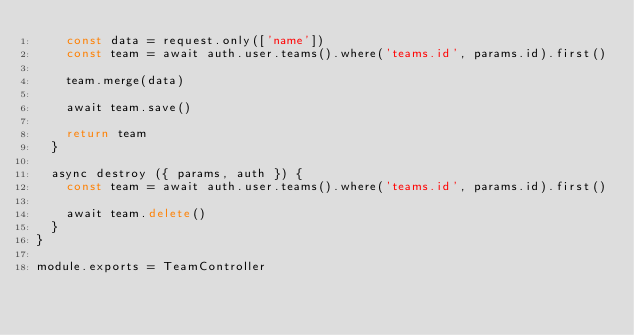Convert code to text. <code><loc_0><loc_0><loc_500><loc_500><_JavaScript_>    const data = request.only(['name'])
    const team = await auth.user.teams().where('teams.id', params.id).first()

    team.merge(data)

    await team.save()

    return team
  }

  async destroy ({ params, auth }) {
    const team = await auth.user.teams().where('teams.id', params.id).first()

    await team.delete()
  }
}

module.exports = TeamController
</code> 